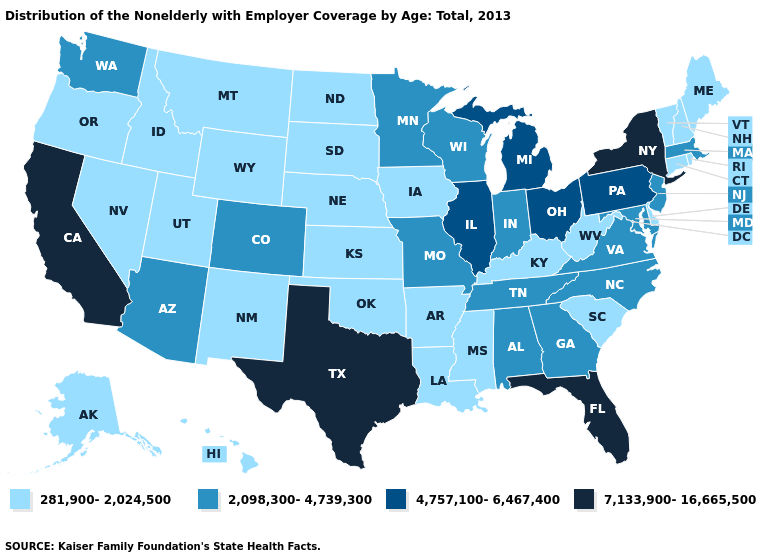How many symbols are there in the legend?
Write a very short answer. 4. Among the states that border Illinois , does Indiana have the lowest value?
Short answer required. No. What is the lowest value in states that border Tennessee?
Quick response, please. 281,900-2,024,500. What is the lowest value in states that border Rhode Island?
Quick response, please. 281,900-2,024,500. Name the states that have a value in the range 281,900-2,024,500?
Give a very brief answer. Alaska, Arkansas, Connecticut, Delaware, Hawaii, Idaho, Iowa, Kansas, Kentucky, Louisiana, Maine, Mississippi, Montana, Nebraska, Nevada, New Hampshire, New Mexico, North Dakota, Oklahoma, Oregon, Rhode Island, South Carolina, South Dakota, Utah, Vermont, West Virginia, Wyoming. What is the lowest value in the West?
Be succinct. 281,900-2,024,500. Does Alaska have the lowest value in the USA?
Answer briefly. Yes. What is the value of California?
Keep it brief. 7,133,900-16,665,500. Name the states that have a value in the range 2,098,300-4,739,300?
Give a very brief answer. Alabama, Arizona, Colorado, Georgia, Indiana, Maryland, Massachusetts, Minnesota, Missouri, New Jersey, North Carolina, Tennessee, Virginia, Washington, Wisconsin. What is the value of Idaho?
Keep it brief. 281,900-2,024,500. Name the states that have a value in the range 281,900-2,024,500?
Write a very short answer. Alaska, Arkansas, Connecticut, Delaware, Hawaii, Idaho, Iowa, Kansas, Kentucky, Louisiana, Maine, Mississippi, Montana, Nebraska, Nevada, New Hampshire, New Mexico, North Dakota, Oklahoma, Oregon, Rhode Island, South Carolina, South Dakota, Utah, Vermont, West Virginia, Wyoming. Does the first symbol in the legend represent the smallest category?
Write a very short answer. Yes. What is the lowest value in states that border Connecticut?
Be succinct. 281,900-2,024,500. What is the value of Wyoming?
Answer briefly. 281,900-2,024,500. Does the map have missing data?
Answer briefly. No. 